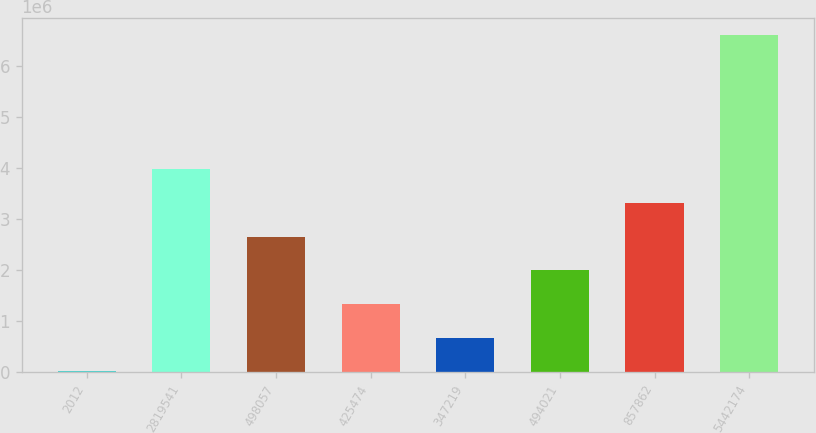Convert chart to OTSL. <chart><loc_0><loc_0><loc_500><loc_500><bar_chart><fcel>2012<fcel>2819541<fcel>498057<fcel>425474<fcel>347219<fcel>494021<fcel>857862<fcel>5442174<nl><fcel>2011<fcel>3.97029e+06<fcel>2.64753e+06<fcel>1.32477e+06<fcel>663391<fcel>1.98615e+06<fcel>3.30891e+06<fcel>6.61581e+06<nl></chart> 